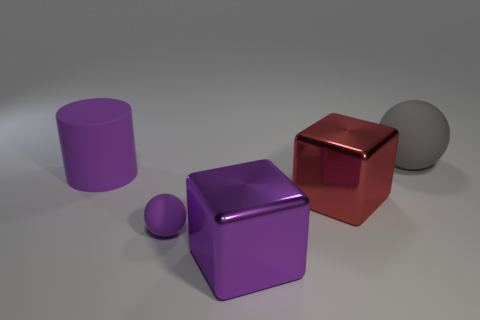Add 5 blocks. How many objects exist? 10 Subtract all cylinders. How many objects are left? 4 Subtract 0 red spheres. How many objects are left? 5 Subtract all tiny red shiny spheres. Subtract all large metallic blocks. How many objects are left? 3 Add 2 gray objects. How many gray objects are left? 3 Add 1 purple spheres. How many purple spheres exist? 2 